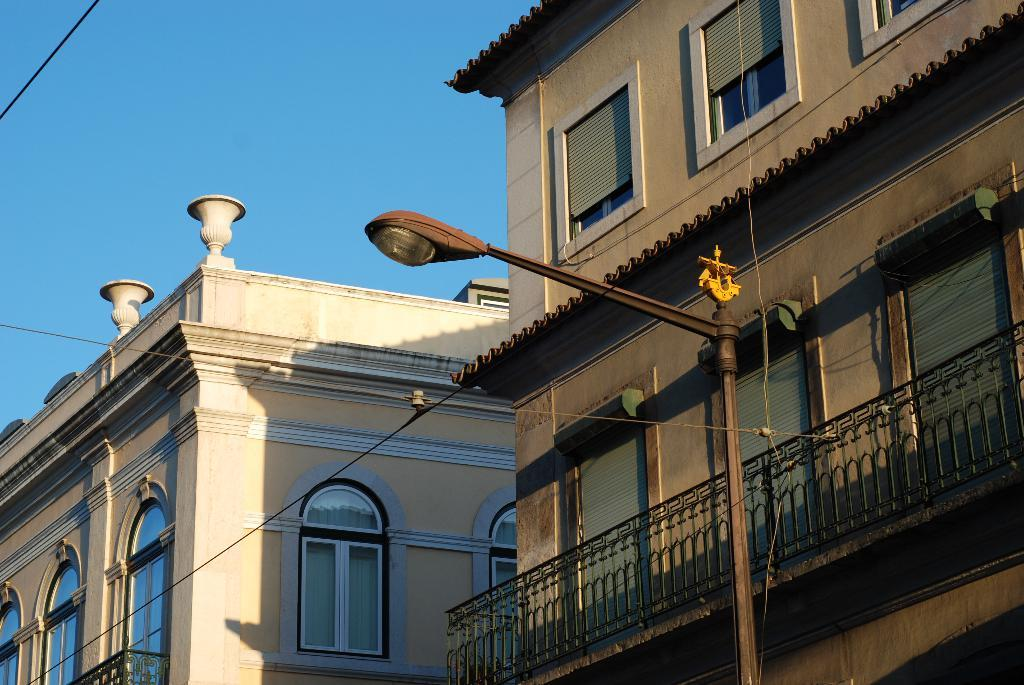What type of structures can be seen in the image? There are buildings in the image. What material are the windows of the buildings made of? The buildings have glass windows. What type of barrier is present in the image? There is a metal fence in the image. What type of lighting fixture is present in the image? A street light is present in the image. What type of infrastructure is visible in the image? Cable wires are visible in the image. What part of the natural environment is visible in the image? The sky is visible in the image. What type of silver is being exchanged in the image? There is no silver or exchange of any kind present in the image. 